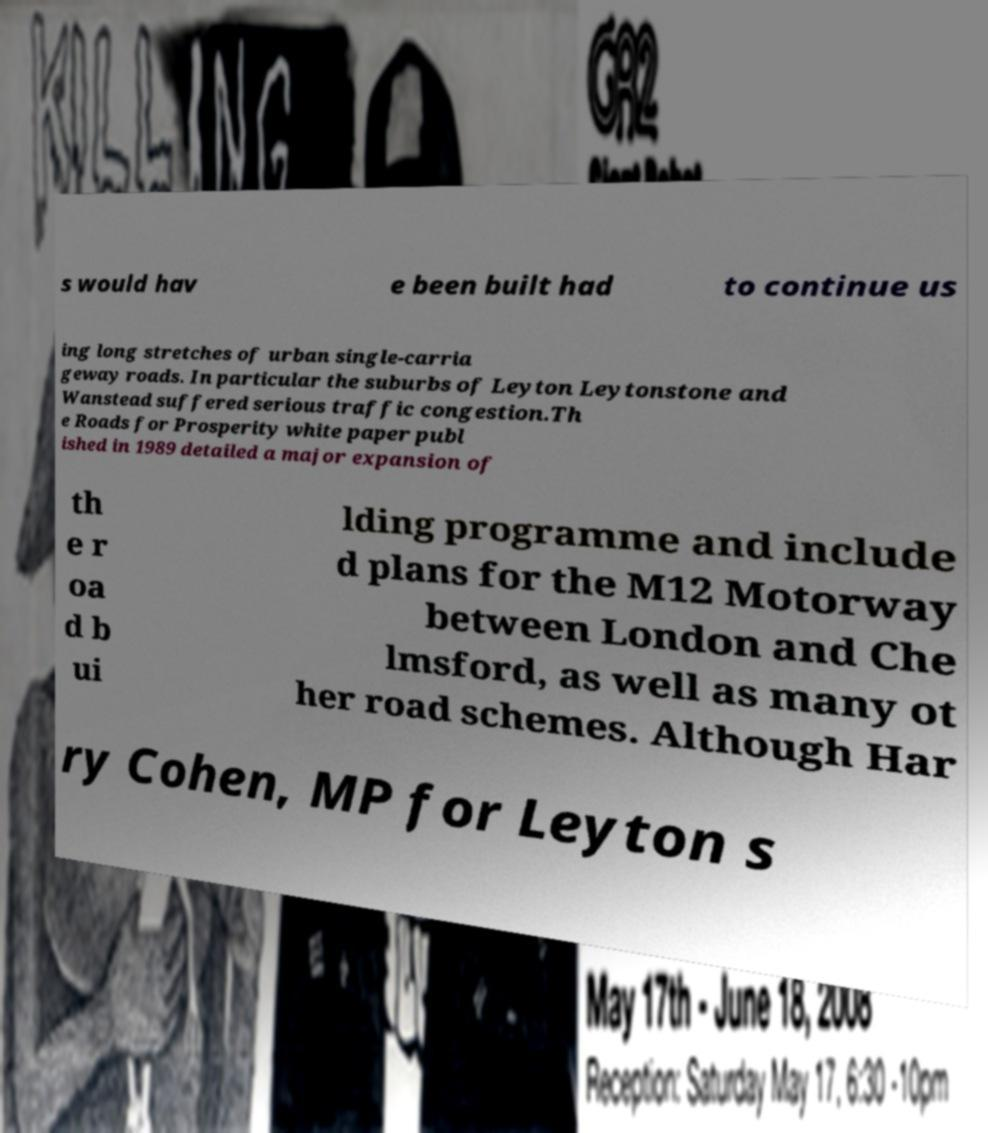Please read and relay the text visible in this image. What does it say? s would hav e been built had to continue us ing long stretches of urban single-carria geway roads. In particular the suburbs of Leyton Leytonstone and Wanstead suffered serious traffic congestion.Th e Roads for Prosperity white paper publ ished in 1989 detailed a major expansion of th e r oa d b ui lding programme and include d plans for the M12 Motorway between London and Che lmsford, as well as many ot her road schemes. Although Har ry Cohen, MP for Leyton s 